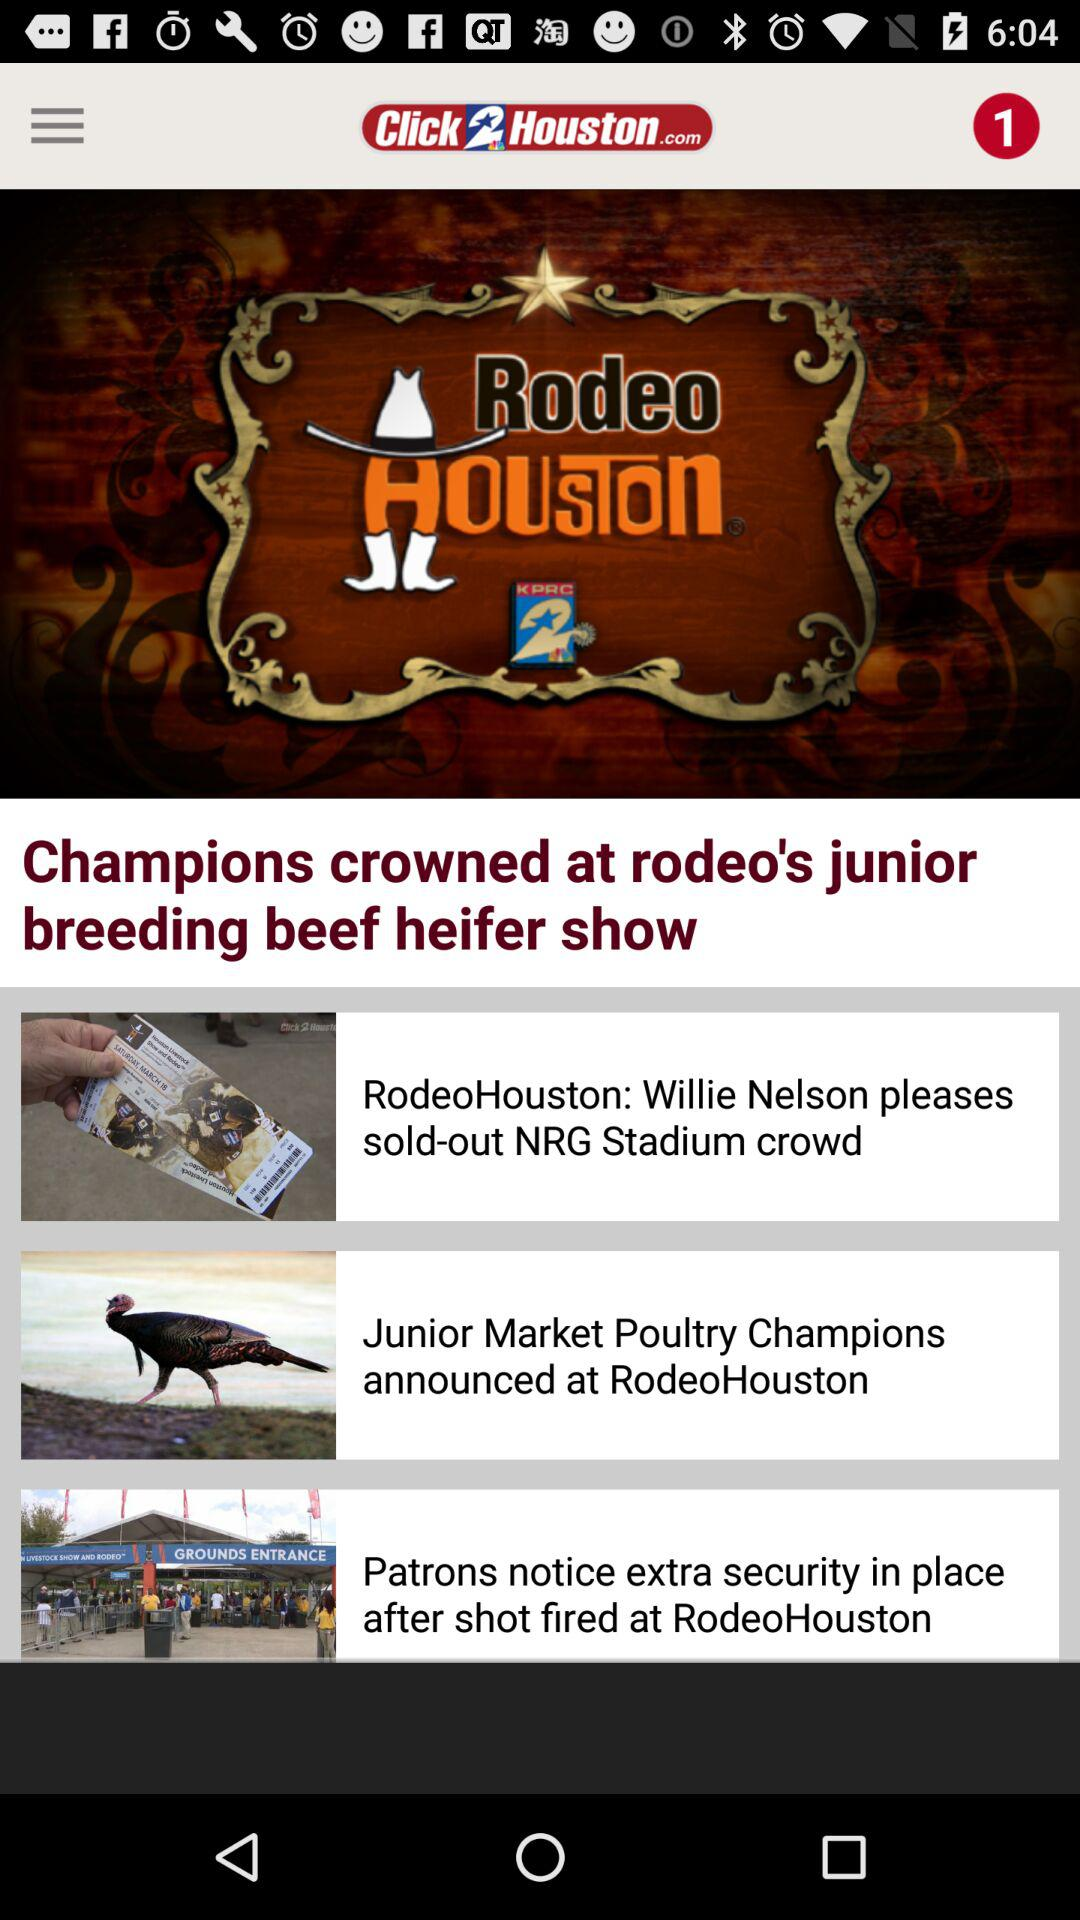What is the application name? The application name is "Click2Houston - KPRC 2". 